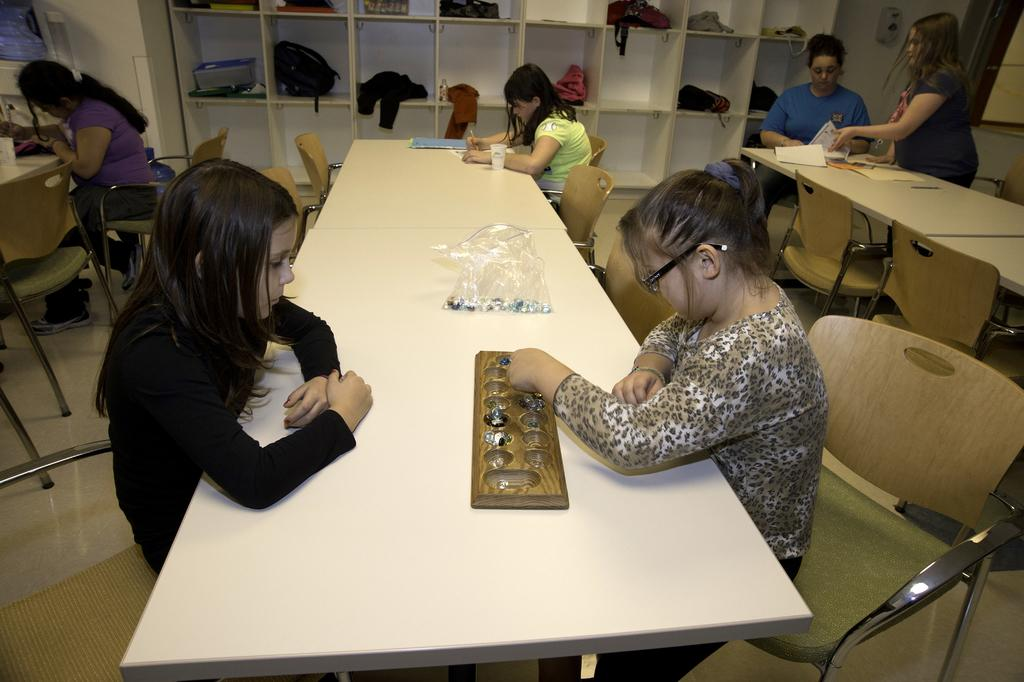How many people are present in the image? There are two people in the image. What are the people doing in the image? The people are seated on chairs and playing a game on a table. Are there any items related to school or travel in the image? Yes, there are backpacks in the image. What can be seen on a shelf in the image? There are books on a shelf in the image. Where is the cactus located in the image? There is no cactus present in the image. What is the value of the game being played by the people in the image? The value of the game cannot be determined from the image alone, as it depends on the players' perspectives and experiences. 